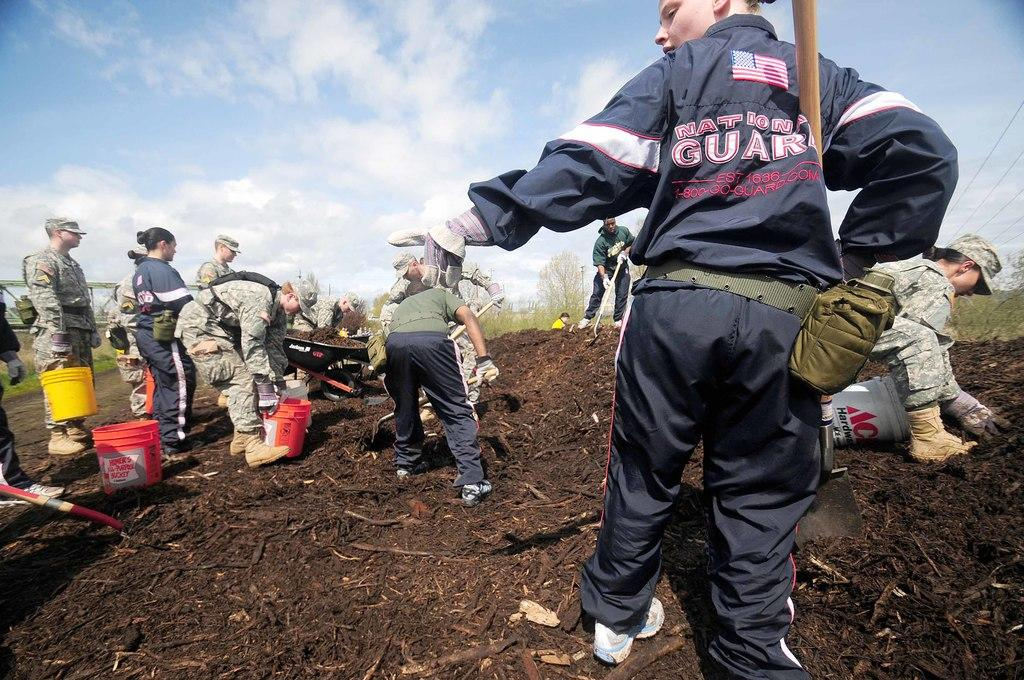What are the main subjects in the center of the image? There are persons standing in the center of the image. What objects can be seen in the image besides the persons? There are buckets in the image. What type of vegetation is visible in the background of the image? There are plants in the background of the image. How would you describe the weather based on the sky in the image? The sky is cloudy in the image, suggesting a potentially overcast or cloudy day. How many leaves can be seen on the foot of the person in the image? There are no leaves present in the image, and the person's foot is not visible. 